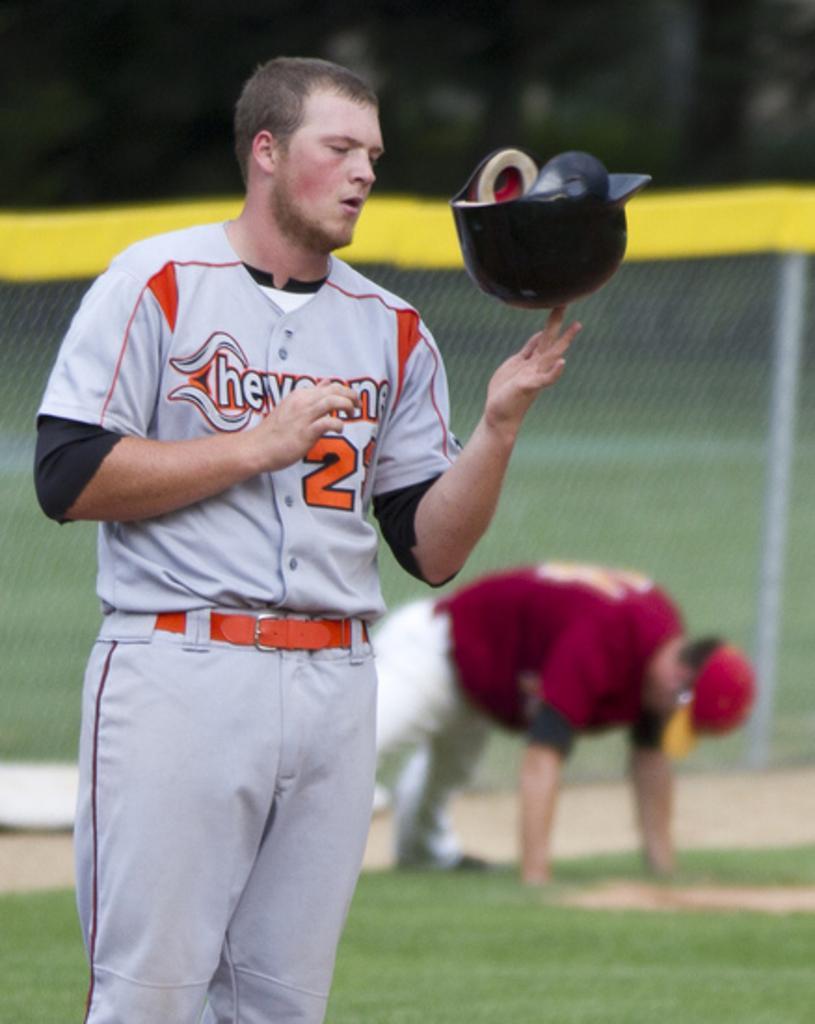How would you summarize this image in a sentence or two? There is a player he is standing in the ground and holding a helmet with his left hand tip and looking at the helmet, behind him another player is is performing some activity and behind them there is a fencing around the ground and the background is blurry. 